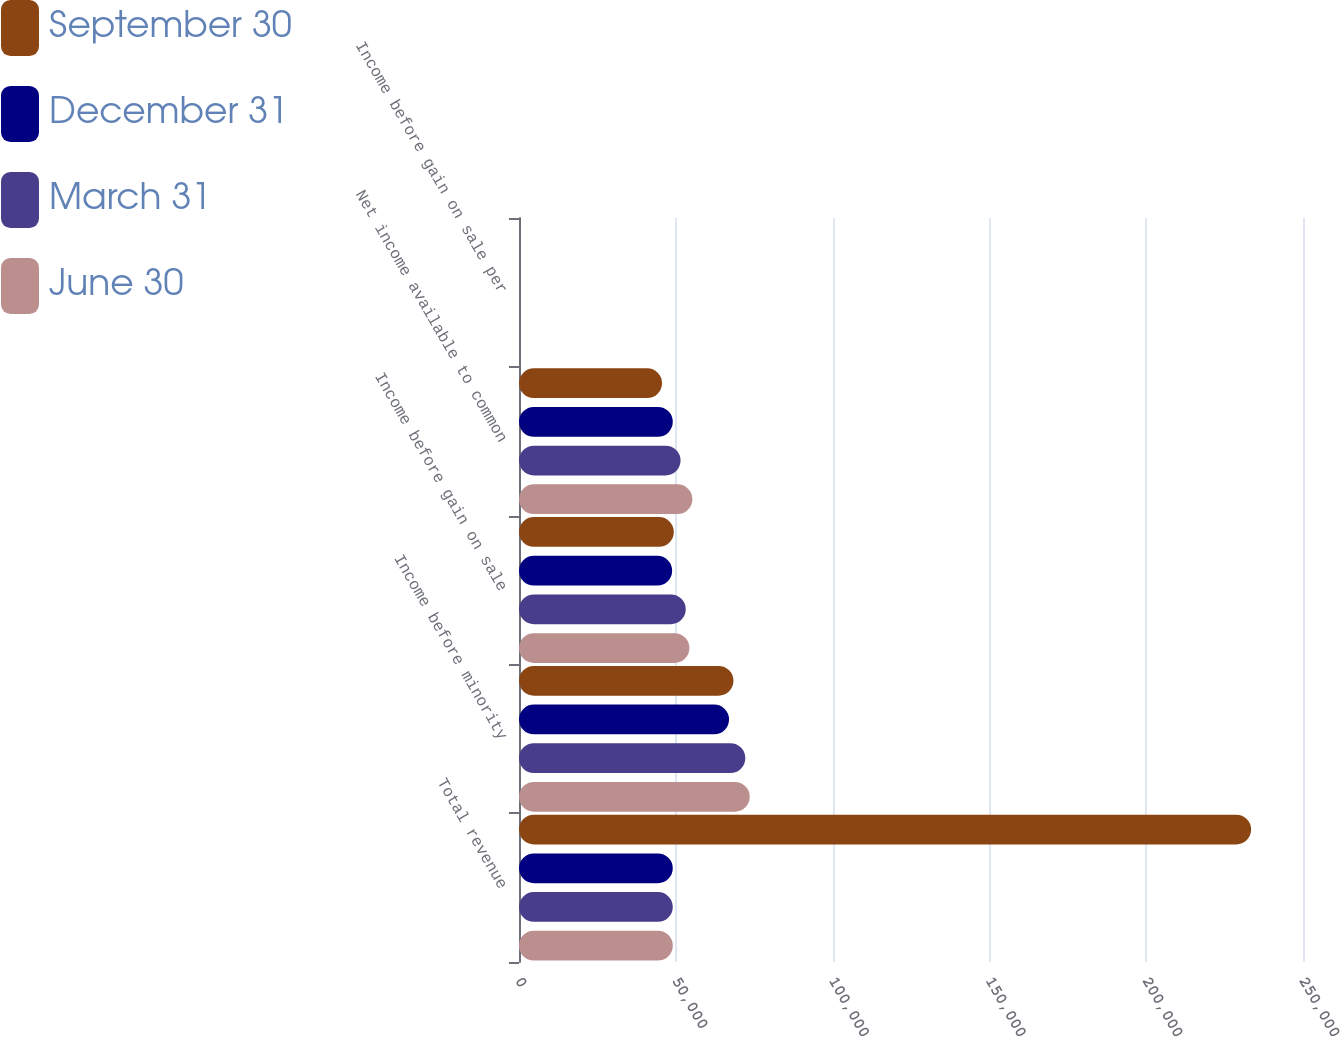Convert chart to OTSL. <chart><loc_0><loc_0><loc_500><loc_500><stacked_bar_chart><ecel><fcel>Total revenue<fcel>Income before minority<fcel>Income before gain on sale<fcel>Net income available to common<fcel>Income before gain on sale per<nl><fcel>September 30<fcel>233456<fcel>68387<fcel>49363<fcel>45607<fcel>0.52<nl><fcel>December 31<fcel>49038<fcel>66973<fcel>48835<fcel>49038<fcel>0.51<nl><fcel>March 31<fcel>49038<fcel>72162<fcel>53168<fcel>51515<fcel>0.56<nl><fcel>June 30<fcel>49038<fcel>73581<fcel>54344<fcel>55280<fcel>0.57<nl></chart> 